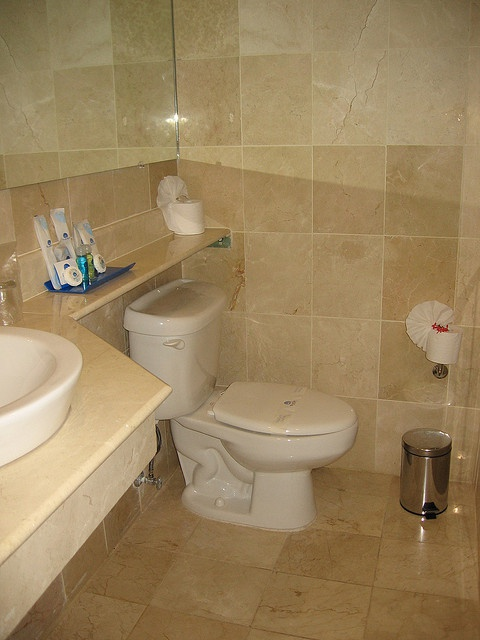Describe the objects in this image and their specific colors. I can see toilet in gray and tan tones, sink in gray, tan, and beige tones, toothbrush in gray, darkgray, and tan tones, and bottle in gray and teal tones in this image. 